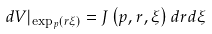Convert formula to latex. <formula><loc_0><loc_0><loc_500><loc_500>d V | _ { \exp _ { p } \left ( r \xi \right ) } = J \left ( p , r , \xi \right ) d r d \xi</formula> 